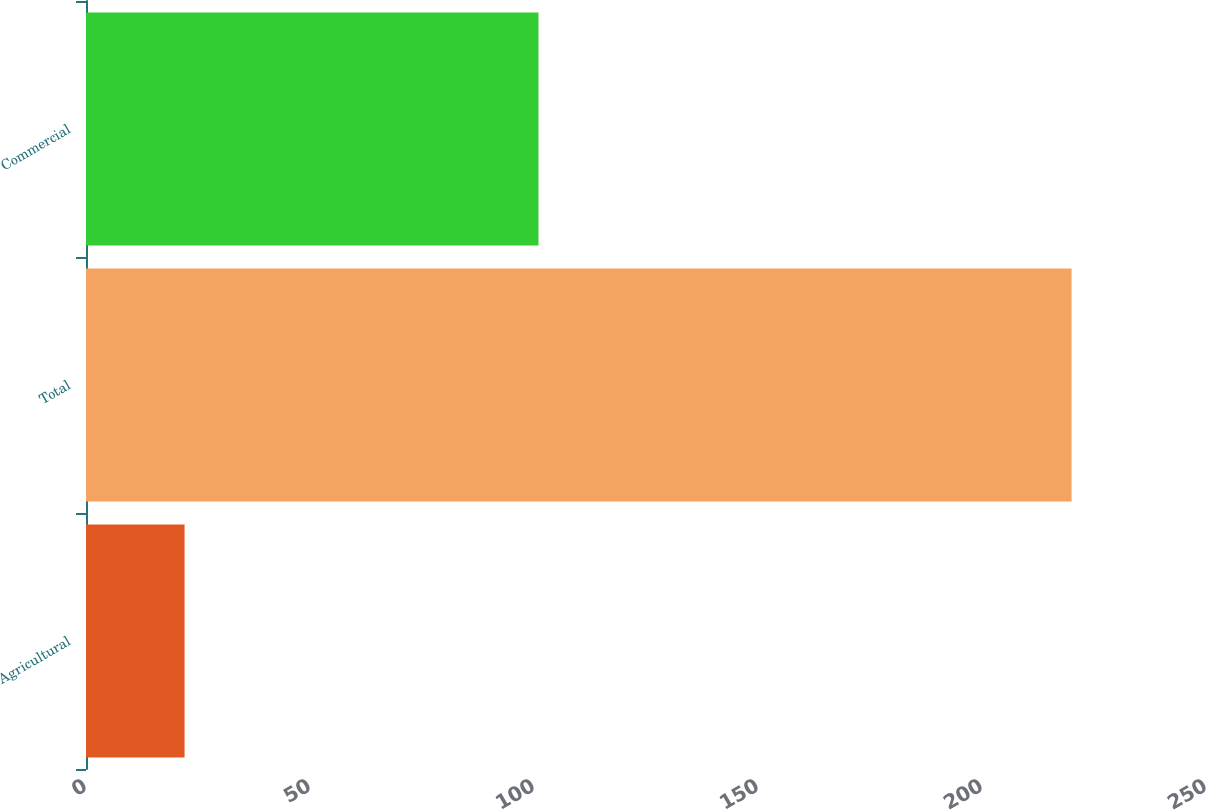Convert chart to OTSL. <chart><loc_0><loc_0><loc_500><loc_500><bar_chart><fcel>Agricultural<fcel>Total<fcel>Commercial<nl><fcel>22<fcel>220<fcel>101<nl></chart> 